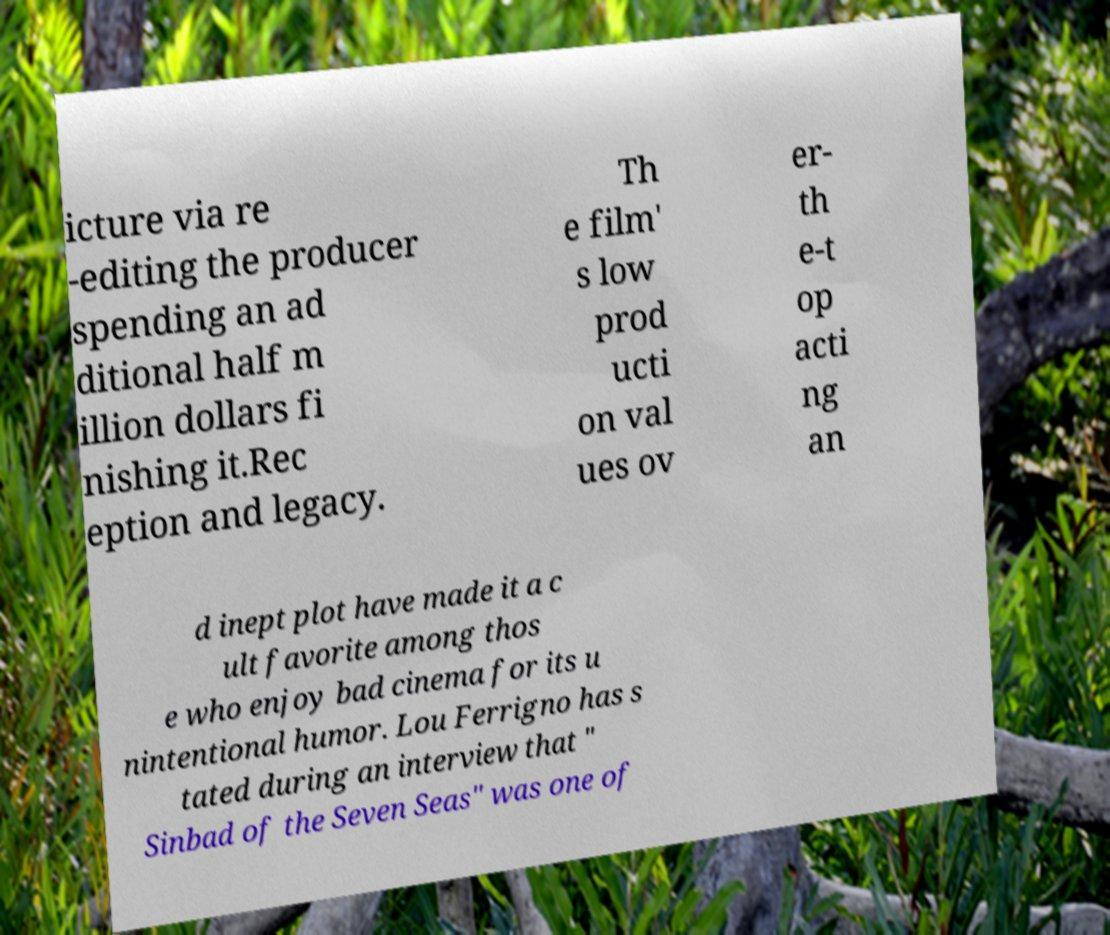Could you extract and type out the text from this image? icture via re -editing the producer spending an ad ditional half m illion dollars fi nishing it.Rec eption and legacy. Th e film' s low prod ucti on val ues ov er- th e-t op acti ng an d inept plot have made it a c ult favorite among thos e who enjoy bad cinema for its u nintentional humor. Lou Ferrigno has s tated during an interview that " Sinbad of the Seven Seas" was one of 